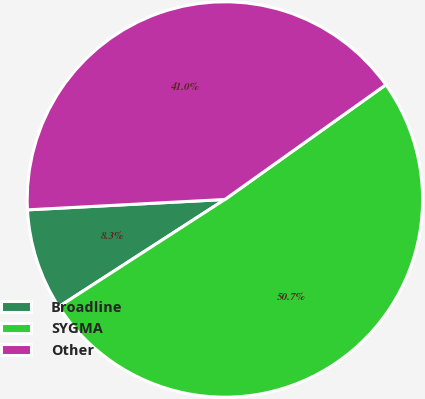<chart> <loc_0><loc_0><loc_500><loc_500><pie_chart><fcel>Broadline<fcel>SYGMA<fcel>Other<nl><fcel>8.29%<fcel>50.73%<fcel>40.98%<nl></chart> 